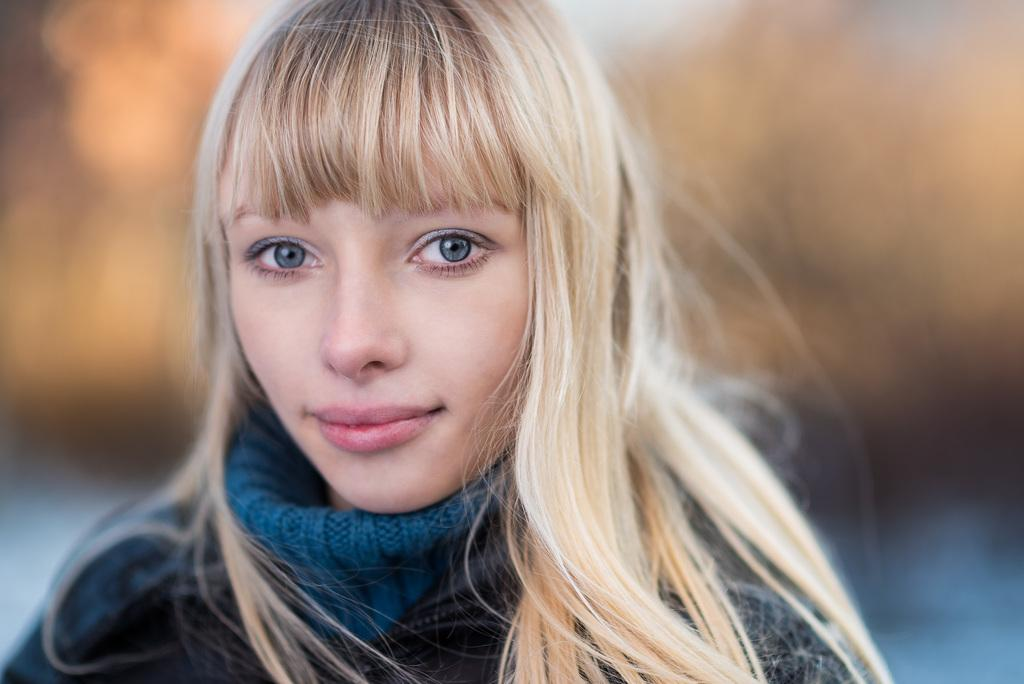Who is present in the image? There is a woman in the image. What is the woman wearing? The woman is wearing a blue dress. Can you describe the background of the image? The background of the image is blurred. Is the woman's friend in the hospital in the image? There is no indication of a hospital or a friend in the image; it only features a woman wearing a blue dress with a blurred background. 